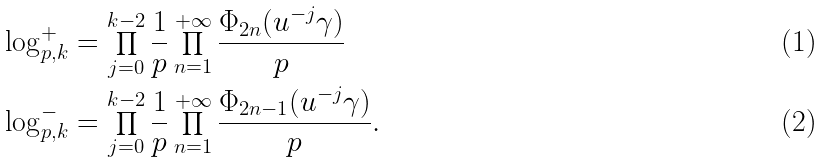Convert formula to latex. <formula><loc_0><loc_0><loc_500><loc_500>\log ^ { + } _ { p , k } & = \prod _ { j = 0 } ^ { k - 2 } \frac { 1 } { p } \prod _ { n = 1 } ^ { + \infty } \frac { \Phi _ { 2 n } ( u ^ { - j } \gamma ) } { p } \\ \log ^ { - } _ { p , k } & = \prod _ { j = 0 } ^ { k - 2 } \frac { 1 } { p } \prod _ { n = 1 } ^ { + \infty } \frac { \Phi _ { 2 n - 1 } ( u ^ { - j } \gamma ) } { p } .</formula> 